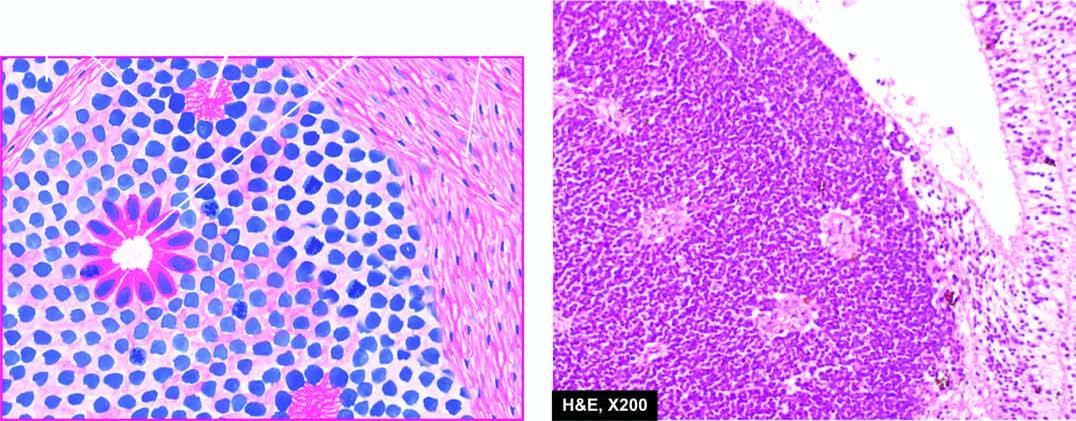what shows undifferentiated retinal cells and the typical rosettes?
Answer the question using a single word or phrase. Tumour arising from the retina 